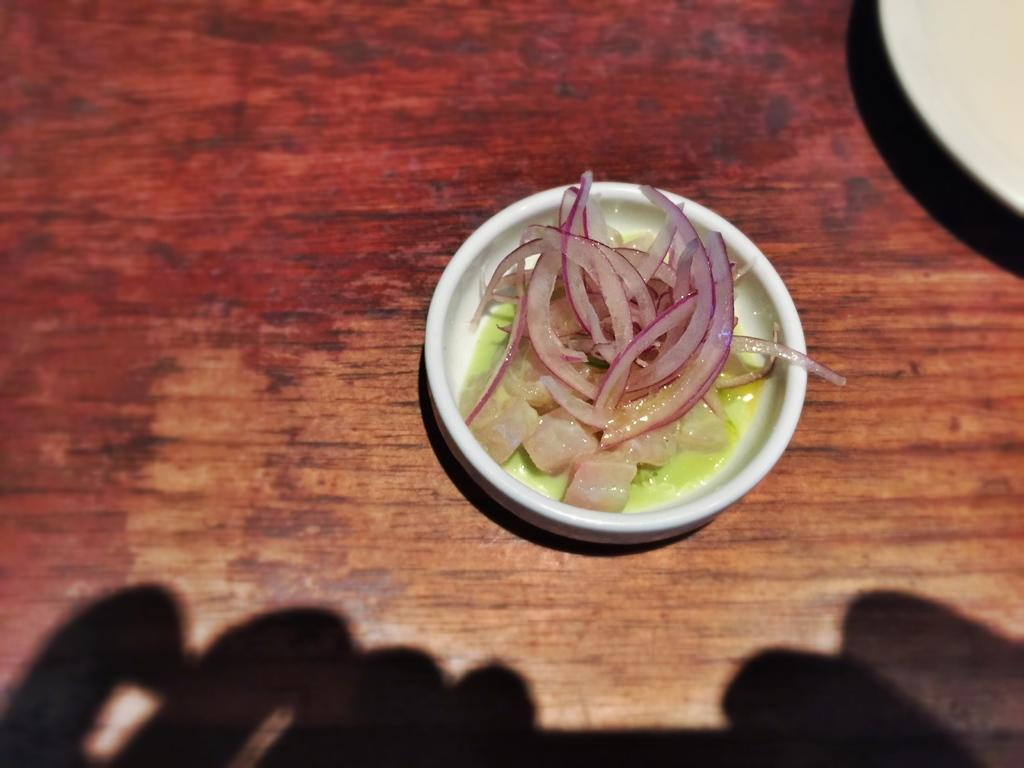What is on the table in the image? There is a cup and a white plate on the table. What is inside the cup? The cup contains onion pieces, liquid, and other food items. How would you describe the appearance of the bottom of the image? The bottom of the image appears to be dark. How many icicles are hanging from the cup in the image? There are no icicles present in the image. What type of glass is used to make the cup in the image? The image does not provide information about the type of glass used to make the cup. 